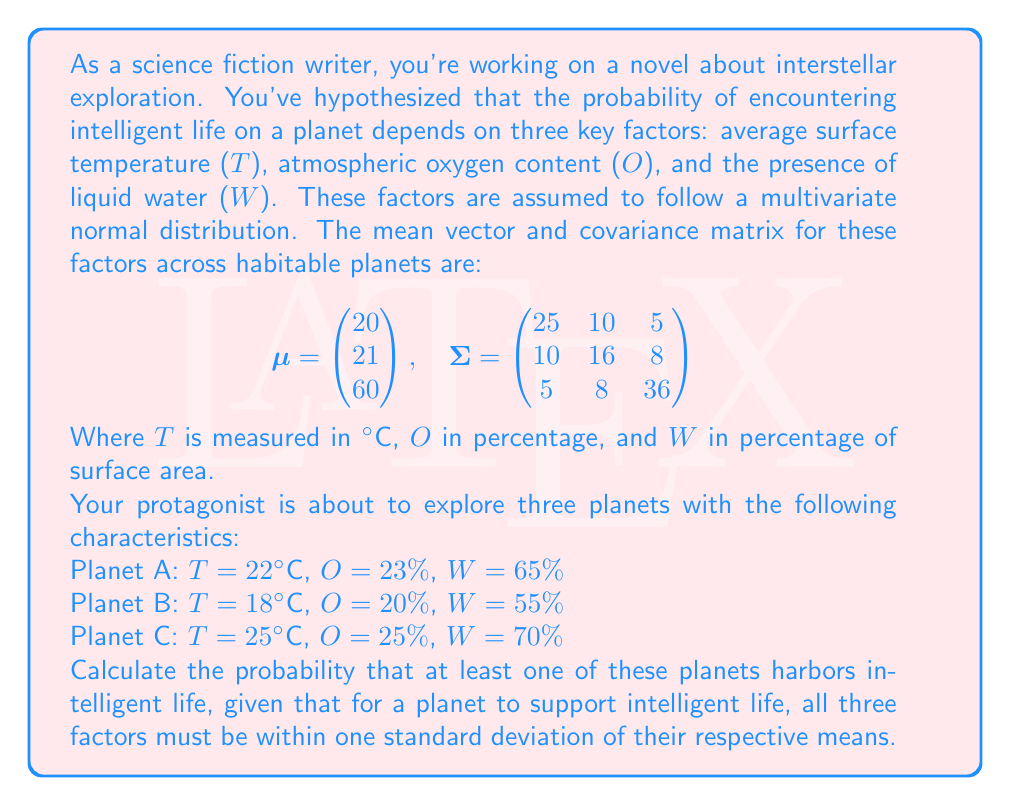Give your solution to this math problem. To solve this problem, we'll follow these steps:

1. Calculate the standard deviations for each factor.
2. Determine the ranges for each factor that are within one standard deviation of the mean.
3. Use the multivariate normal distribution to calculate the probability for each planet.
4. Combine the probabilities to find the probability of at least one planet harboring intelligent life.

Step 1: Calculate standard deviations
The standard deviations are the square roots of the diagonal elements of the covariance matrix:

$$\sigma_T = \sqrt{25} = 5$$
$$\sigma_O = \sqrt{16} = 4$$
$$\sigma_W = \sqrt{36} = 6$$

Step 2: Determine the ranges
For each factor, the range within one standard deviation of the mean is:

T: $20 \pm 5 = [15, 25]$
O: $21 \pm 4 = [17, 25]$
W: $60 \pm 6 = [54, 66]$

Step 3: Calculate probabilities for each planet
We need to calculate the probability that all three factors fall within their respective ranges for each planet. We can use the multivariate normal cumulative distribution function (CDF) for this.

Let $\Phi_3(\mathbf{x}; \boldsymbol{\mu}, \boldsymbol{\Sigma})$ be the trivariate normal CDF. The probability for each planet is:

$$P(\text{planet supports life}) = \Phi_3(\mathbf{x}_u; \boldsymbol{\mu}, \boldsymbol{\Sigma}) - \Phi_3(\mathbf{x}_l; \boldsymbol{\mu}, \boldsymbol{\Sigma})$$

Where $\mathbf{x}_u = (25, 25, 66)$ and $\mathbf{x}_l = (15, 17, 54)$ are the upper and lower bounds of the ranges.

Using a statistical software or numerical integration method, we can calculate these probabilities:

Planet A: $P_A \approx 0.7823$
Planet B: $P_B \approx 0.6914$
Planet C: $P_C \approx 0.5237$

Step 4: Combine probabilities
The probability that at least one planet harbors intelligent life is the complement of the probability that none of them do:

$$P(\text{at least one}) = 1 - P(\text{none})$$
$$= 1 - (1-P_A)(1-P_B)(1-P_C)$$
$$= 1 - (1-0.7823)(1-0.6914)(1-0.5237)$$
$$= 1 - (0.2177)(0.3086)(0.4763)$$
$$= 1 - 0.0320$$
$$= 0.9680$$
Answer: The probability that at least one of the three planets harbors intelligent life is approximately 0.9680 or 96.80%. 